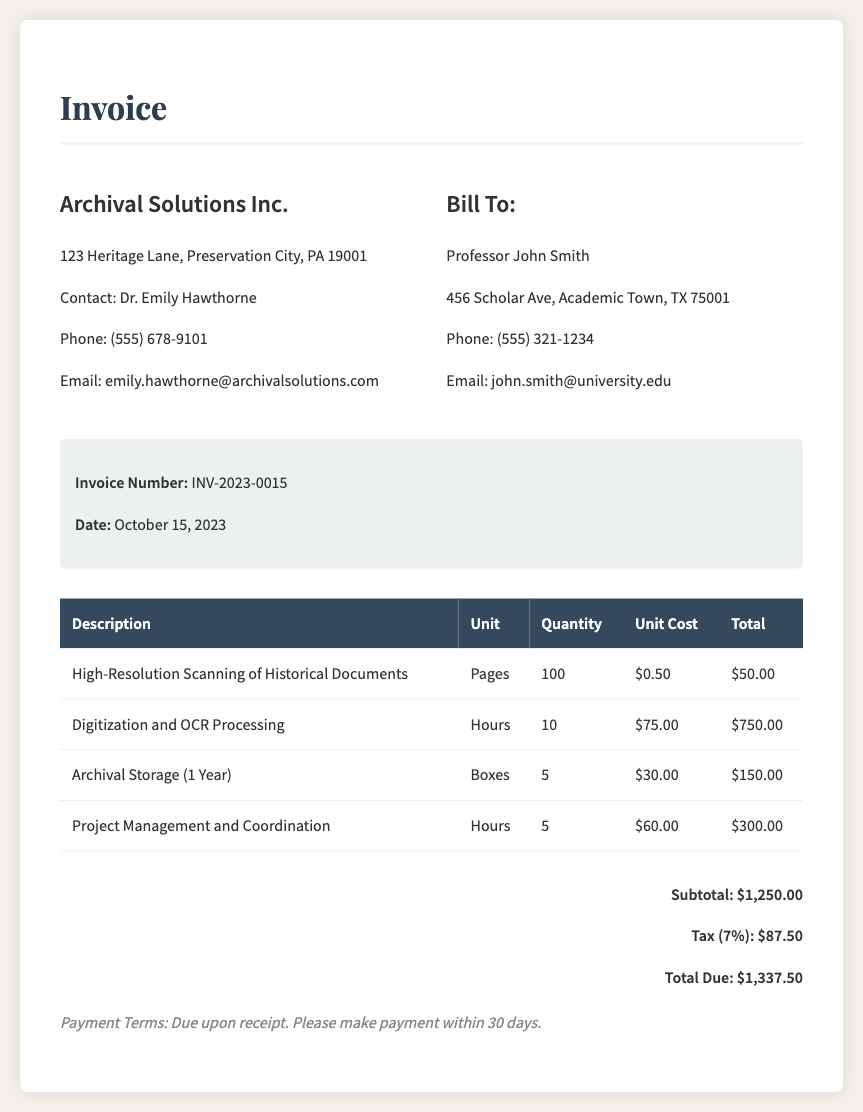What is the name of the service provider? The name of the service provider is listed at the top of the invoice.
Answer: Archival Solutions Inc What is the total amount due? The total amount due is clearly stated in the total section of the invoice.
Answer: $1,337.50 What is the invoice number? The invoice number is provided in the invoice details section.
Answer: INV-2023-0015 What is the date of the invoice? The date of the invoice is specified in the invoice details section.
Answer: October 15, 2023 How many pages were scanned? The quantity of pages scanned is detailed in the first table row.
Answer: 100 What is the unit cost for digitization and OCR processing? The unit cost for this service can be found in the second table row.
Answer: $75.00 What is the subtotal before tax? The subtotal is calculated from the listed services and is shown just before the tax amount.
Answer: $1,250.00 What is the tax percentage applied? The tax percentage is mentioned in the total section of the invoice.
Answer: 7% What are the payment terms? The payment terms are provided at the bottom of the invoice.
Answer: Due upon receipt 